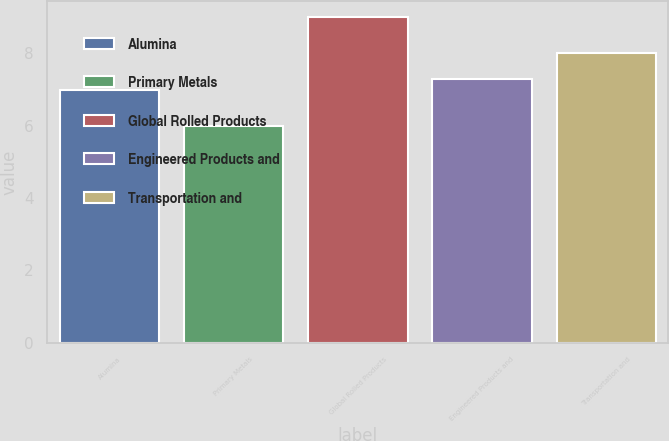Convert chart. <chart><loc_0><loc_0><loc_500><loc_500><bar_chart><fcel>Alumina<fcel>Primary Metals<fcel>Global Rolled Products<fcel>Engineered Products and<fcel>Transportation and<nl><fcel>7<fcel>6<fcel>9<fcel>7.3<fcel>8<nl></chart> 